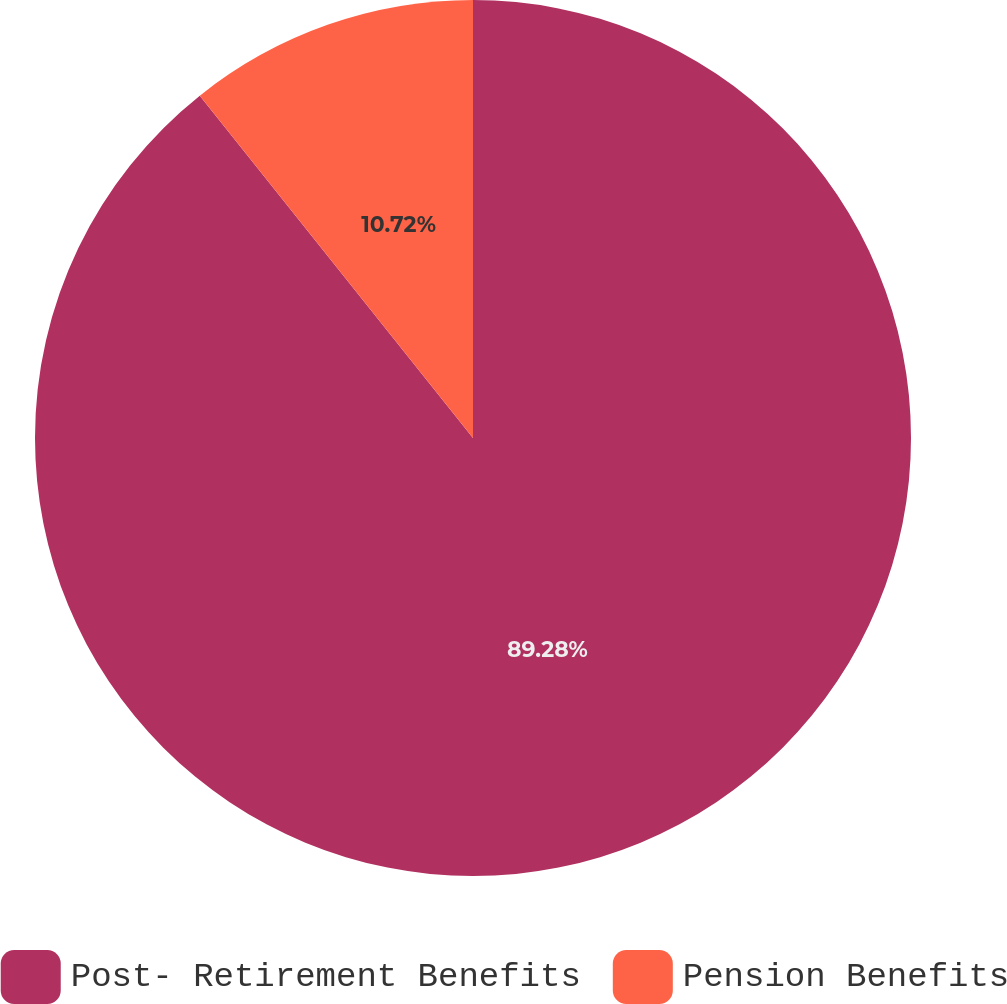Convert chart. <chart><loc_0><loc_0><loc_500><loc_500><pie_chart><fcel>Post- Retirement Benefits<fcel>Pension Benefits<nl><fcel>89.28%<fcel>10.72%<nl></chart> 